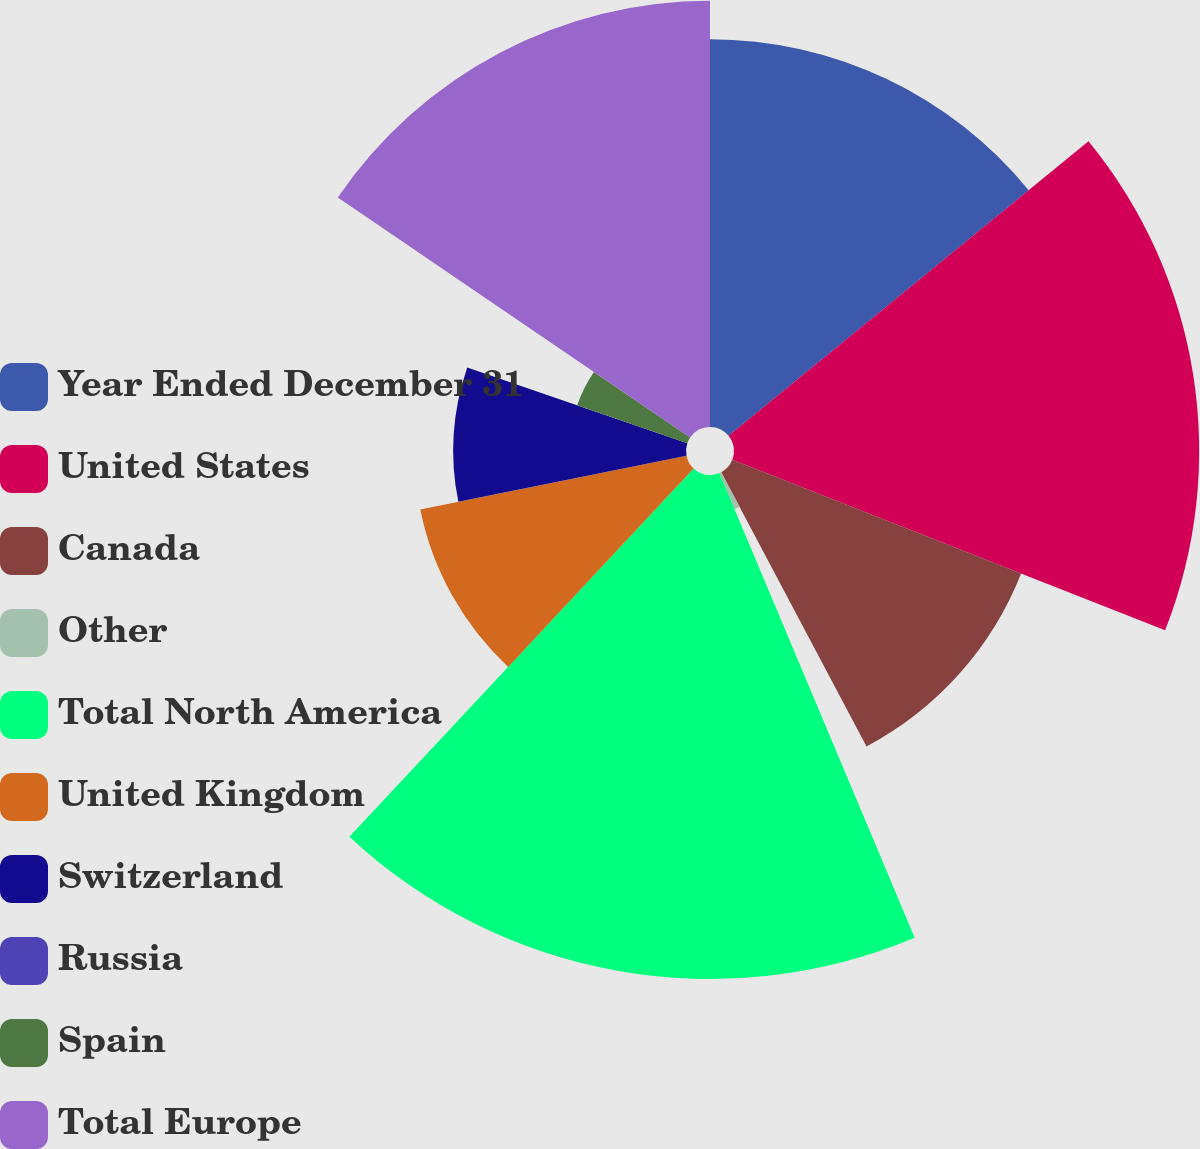<chart> <loc_0><loc_0><loc_500><loc_500><pie_chart><fcel>Year Ended December 31<fcel>United States<fcel>Canada<fcel>Other<fcel>Total North America<fcel>United Kingdom<fcel>Switzerland<fcel>Russia<fcel>Spain<fcel>Total Europe<nl><fcel>14.08%<fcel>16.89%<fcel>11.27%<fcel>1.42%<fcel>18.3%<fcel>9.86%<fcel>8.45%<fcel>0.01%<fcel>4.23%<fcel>15.48%<nl></chart> 